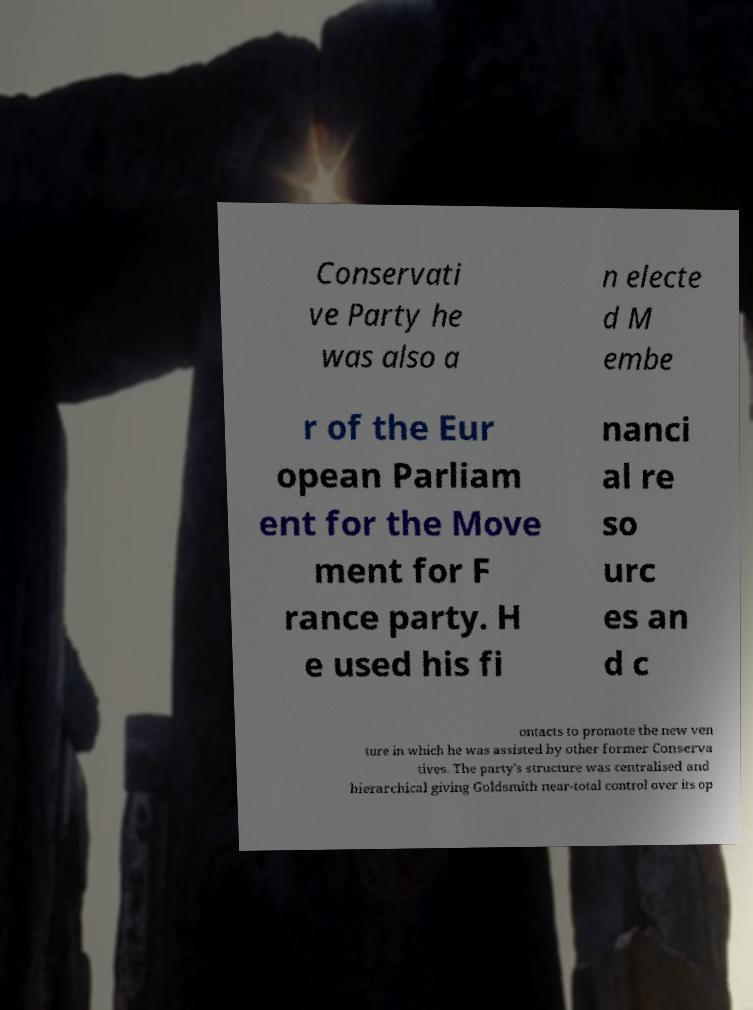Please read and relay the text visible in this image. What does it say? Conservati ve Party he was also a n electe d M embe r of the Eur opean Parliam ent for the Move ment for F rance party. H e used his fi nanci al re so urc es an d c ontacts to promote the new ven ture in which he was assisted by other former Conserva tives. The party's structure was centralised and hierarchical giving Goldsmith near-total control over its op 